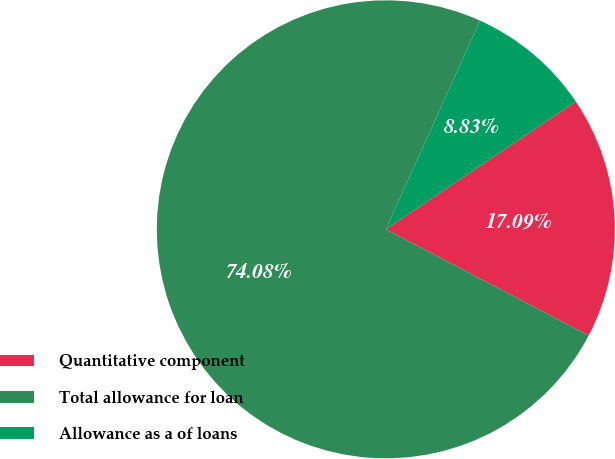<chart> <loc_0><loc_0><loc_500><loc_500><pie_chart><fcel>Quantitative component<fcel>Total allowance for loan<fcel>Allowance as a of loans<nl><fcel>17.09%<fcel>74.07%<fcel>8.83%<nl></chart> 